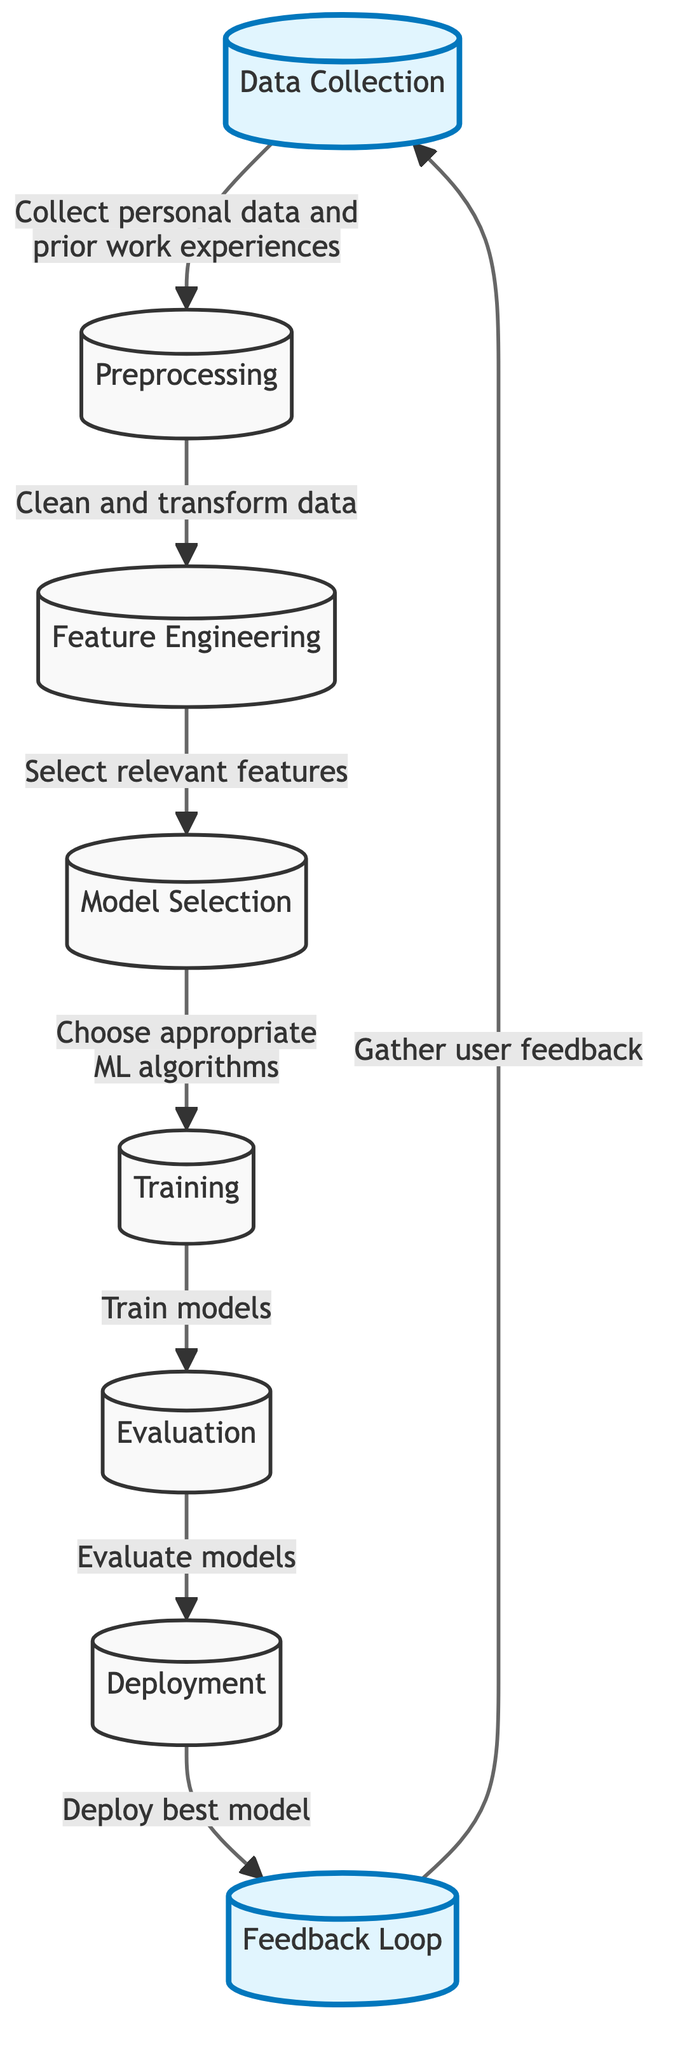What is the first step in this machine learning framework? The diagram indicates that the first step is labeled as "Data Collection," which is the initial action in the machine learning process depicted.
Answer: Data Collection How many nodes are present in the diagram? By counting the nodes from "Data Collection" to "Feedback Loop," we see there are eight nodes total in the diagram.
Answer: Eight What is the last step in the flowchart? The last step listed in the diagram is "Feedback Loop," which shows the iterative nature of the model after deployment.
Answer: Feedback Loop What type of data is collected in the first step? The first arrow indicates that personal data and prior work experiences are collected during the "Data Collection" step.
Answer: Personal data and prior work experiences In which step is the model evaluated? The "Evaluation" step, shown as the sixth node, is where the models are assessed based on their performance.
Answer: Evaluation Which step follows "Model Selection"? According to the flow of the diagram, the step that follows "Model Selection" is "Training," where the chosen model is trained with relevant data.
Answer: Training What is the purpose of the "Feedback Loop" node? The "Feedback Loop" node serves to gather user feedback, allowing for continuous improvement of the model based on real-world performance and user input.
Answer: Gather user feedback What happens during the "Preprocessing" step? "Preprocessing" involves cleaning and transforming the collected data to ensure it is suitable for analysis in the subsequent steps.
Answer: Clean and transform data Which step involves choosing appropriate machine learning algorithms? The "Model Selection" step explicitly states that this is where the appropriate machine learning algorithms are chosen to build the model.
Answer: Model Selection 